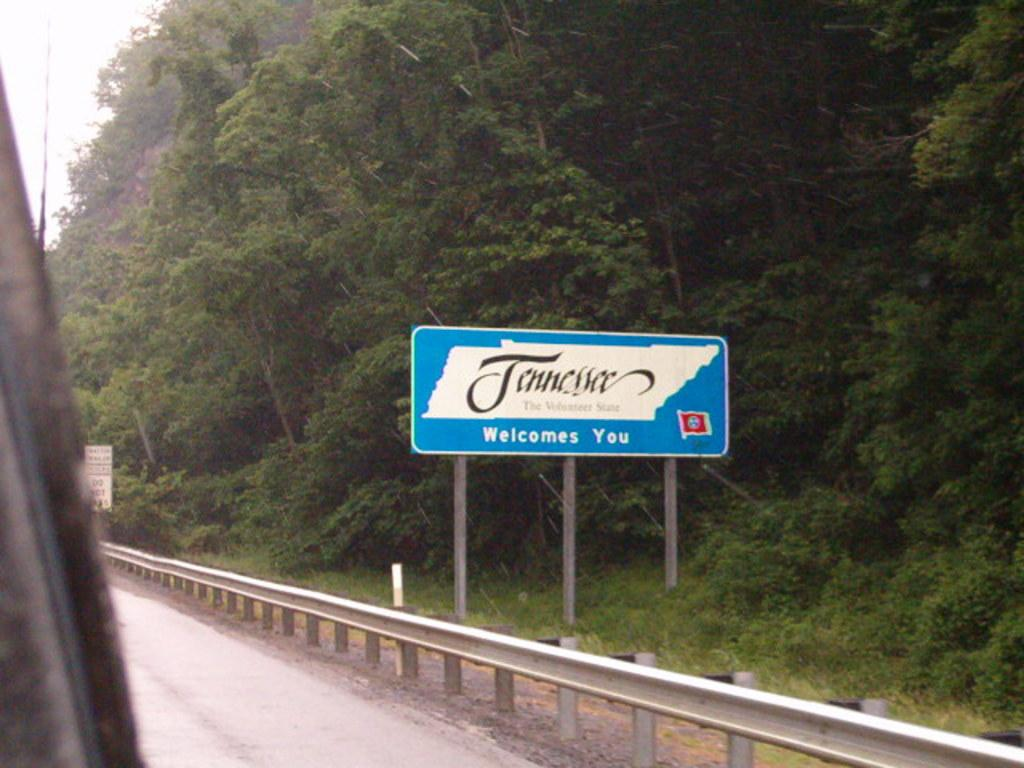What is the main feature of the image? There is a road in the image. What can be seen near the road? There is fencing near the road. What else is present in the image? There is a board with poles in the image. What is written on the board? Something is written on the board. What type of natural elements are visible in the image? There are trees in the image. Can you hear the voice of the magic stream in the image? There is no mention of magic or a stream in the image, so it is not possible to hear a voice associated with them. 